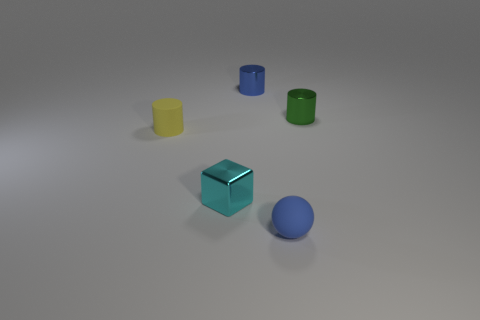What number of cylinders have the same material as the blue sphere?
Your answer should be compact. 1. What is the blue thing that is in front of the blue cylinder made of?
Ensure brevity in your answer.  Rubber. What is the shape of the metal thing that is left of the blue thing behind the object that is to the left of the small shiny cube?
Your response must be concise. Cube. There is a small object that is in front of the small cyan shiny object; is its color the same as the tiny shiny object behind the tiny green cylinder?
Offer a very short reply. Yes. Are there fewer small green shiny objects that are left of the small yellow matte cylinder than matte things in front of the shiny cube?
Offer a very short reply. Yes. Are there any other things that have the same shape as the blue matte thing?
Ensure brevity in your answer.  No. There is another small shiny object that is the same shape as the small green shiny object; what is its color?
Your answer should be very brief. Blue. Do the yellow object and the blue thing behind the blue ball have the same shape?
Ensure brevity in your answer.  Yes. How many objects are either small objects that are left of the green object or metallic things that are right of the small metallic block?
Offer a terse response. 5. What is the green thing made of?
Your answer should be very brief. Metal. 